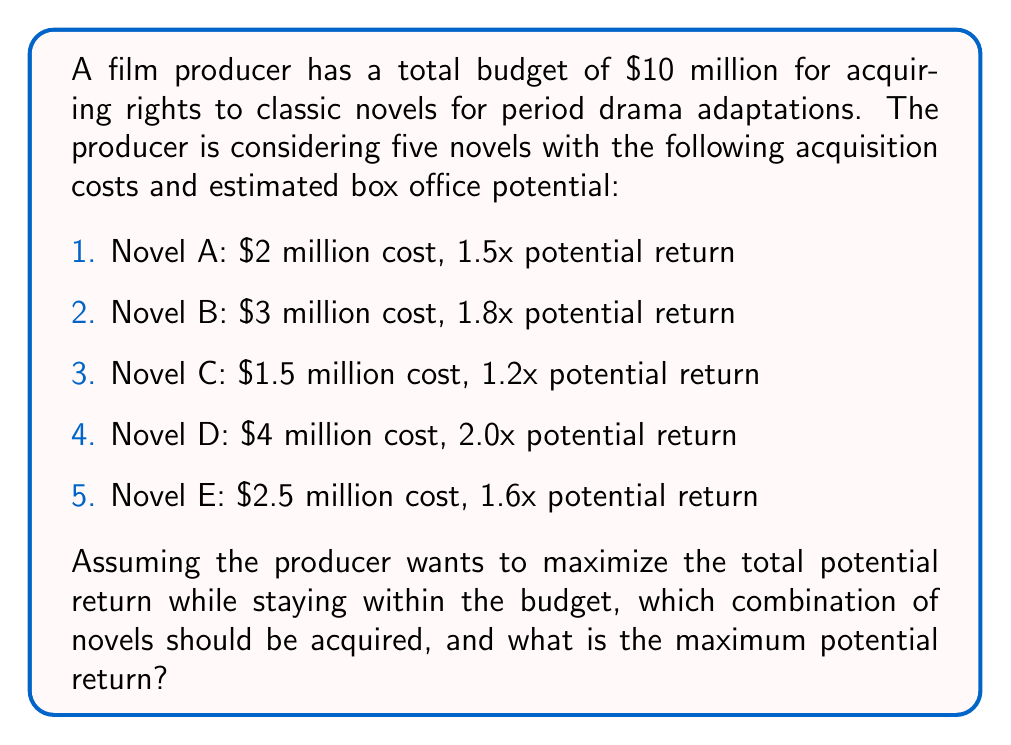What is the answer to this math problem? To solve this problem, we need to use the concept of the Knapsack problem from combinatorial optimization, which is often applied in machine learning for feature selection and resource allocation.

Let's approach this step-by-step:

1. First, let's calculate the potential return for each novel:
   A: $2 million × 1.5 = $3 million
   B: $3 million × 1.8 = $5.4 million
   C: $1.5 million × 1.2 = $1.8 million
   D: $4 million × 2.0 = $8 million
   E: $2.5 million × 1.6 = $4 million

2. Now, we need to find the combination that maximizes the total return while keeping the total cost under $10 million.

3. We can represent this as a binary integer programming problem:

   Maximize: $3x_A + 5.4x_B + 1.8x_C + 8x_D + 4x_E$
   
   Subject to: $2x_A + 3x_B + 1.5x_C + 4x_D + 2.5x_E \leq 10$
   
   Where $x_i \in \{0,1\}$ for $i \in \{A,B,C,D,E\}$

4. While this could be solved using dynamic programming or branch-and-bound algorithms, for this small set, we can enumerate all possible combinations:

   A + B + C: $2 + 3 + 1.5 = 6.5$ million cost, $3 + 5.4 + 1.8 = 10.2$ million return
   A + B + E: $2 + 3 + 2.5 = 7.5$ million cost, $3 + 5.4 + 4 = 12.4$ million return
   A + D: $2 + 4 = 6$ million cost, $3 + 8 = 11$ million return
   B + D: $3 + 4 = 7$ million cost, $5.4 + 8 = 13.4$ million return
   C + D + E: $1.5 + 4 + 2.5 = 8$ million cost, $1.8 + 8 + 4 = 13.8$ million return

5. The optimal combination is C + D + E, which stays within the budget and provides the highest potential return of $13.8 million.
Answer: The optimal combination is to acquire novels C, D, and E, with a total cost of $8 million and a maximum potential return of $13.8 million. 